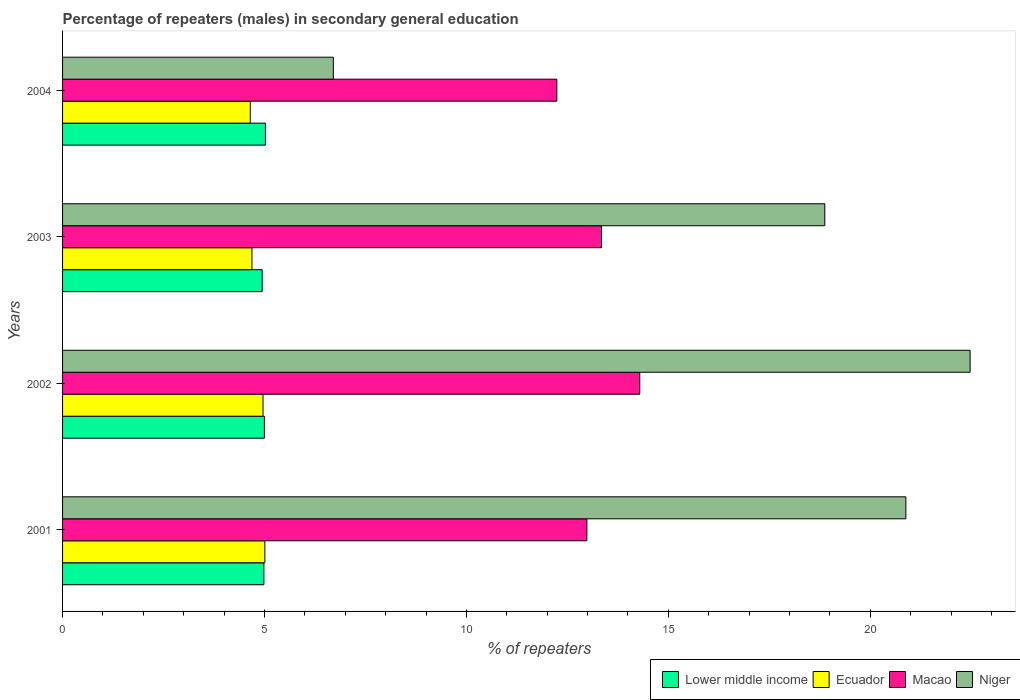How many groups of bars are there?
Offer a terse response. 4. Are the number of bars per tick equal to the number of legend labels?
Offer a terse response. Yes. Are the number of bars on each tick of the Y-axis equal?
Your response must be concise. Yes. How many bars are there on the 1st tick from the top?
Give a very brief answer. 4. How many bars are there on the 3rd tick from the bottom?
Make the answer very short. 4. What is the label of the 3rd group of bars from the top?
Offer a very short reply. 2002. What is the percentage of male repeaters in Lower middle income in 2001?
Provide a succinct answer. 4.99. Across all years, what is the maximum percentage of male repeaters in Macao?
Offer a terse response. 14.29. Across all years, what is the minimum percentage of male repeaters in Niger?
Make the answer very short. 6.71. In which year was the percentage of male repeaters in Macao maximum?
Give a very brief answer. 2002. What is the total percentage of male repeaters in Macao in the graph?
Ensure brevity in your answer.  52.86. What is the difference between the percentage of male repeaters in Lower middle income in 2001 and that in 2004?
Your answer should be very brief. -0.04. What is the difference between the percentage of male repeaters in Niger in 2004 and the percentage of male repeaters in Lower middle income in 2003?
Provide a short and direct response. 1.76. What is the average percentage of male repeaters in Niger per year?
Give a very brief answer. 17.23. In the year 2004, what is the difference between the percentage of male repeaters in Macao and percentage of male repeaters in Niger?
Keep it short and to the point. 5.53. In how many years, is the percentage of male repeaters in Macao greater than 5 %?
Provide a succinct answer. 4. What is the ratio of the percentage of male repeaters in Macao in 2001 to that in 2004?
Make the answer very short. 1.06. Is the percentage of male repeaters in Niger in 2003 less than that in 2004?
Give a very brief answer. No. What is the difference between the highest and the second highest percentage of male repeaters in Macao?
Offer a terse response. 0.95. What is the difference between the highest and the lowest percentage of male repeaters in Lower middle income?
Make the answer very short. 0.08. In how many years, is the percentage of male repeaters in Ecuador greater than the average percentage of male repeaters in Ecuador taken over all years?
Ensure brevity in your answer.  2. Is it the case that in every year, the sum of the percentage of male repeaters in Macao and percentage of male repeaters in Niger is greater than the sum of percentage of male repeaters in Lower middle income and percentage of male repeaters in Ecuador?
Provide a succinct answer. No. What does the 4th bar from the top in 2003 represents?
Keep it short and to the point. Lower middle income. What does the 2nd bar from the bottom in 2001 represents?
Provide a succinct answer. Ecuador. What is the difference between two consecutive major ticks on the X-axis?
Provide a succinct answer. 5. Where does the legend appear in the graph?
Your response must be concise. Bottom right. How are the legend labels stacked?
Your response must be concise. Horizontal. What is the title of the graph?
Provide a succinct answer. Percentage of repeaters (males) in secondary general education. What is the label or title of the X-axis?
Your response must be concise. % of repeaters. What is the % of repeaters in Lower middle income in 2001?
Ensure brevity in your answer.  4.99. What is the % of repeaters of Ecuador in 2001?
Your response must be concise. 5.01. What is the % of repeaters of Macao in 2001?
Your response must be concise. 12.98. What is the % of repeaters in Niger in 2001?
Provide a short and direct response. 20.88. What is the % of repeaters of Lower middle income in 2002?
Ensure brevity in your answer.  5. What is the % of repeaters in Ecuador in 2002?
Your answer should be very brief. 4.96. What is the % of repeaters in Macao in 2002?
Provide a short and direct response. 14.29. What is the % of repeaters in Niger in 2002?
Keep it short and to the point. 22.47. What is the % of repeaters of Lower middle income in 2003?
Give a very brief answer. 4.94. What is the % of repeaters of Ecuador in 2003?
Offer a terse response. 4.69. What is the % of repeaters in Macao in 2003?
Ensure brevity in your answer.  13.34. What is the % of repeaters in Niger in 2003?
Provide a succinct answer. 18.87. What is the % of repeaters in Lower middle income in 2004?
Provide a short and direct response. 5.02. What is the % of repeaters of Ecuador in 2004?
Provide a short and direct response. 4.65. What is the % of repeaters of Macao in 2004?
Your response must be concise. 12.24. What is the % of repeaters in Niger in 2004?
Make the answer very short. 6.71. Across all years, what is the maximum % of repeaters of Lower middle income?
Your answer should be compact. 5.02. Across all years, what is the maximum % of repeaters of Ecuador?
Your answer should be compact. 5.01. Across all years, what is the maximum % of repeaters of Macao?
Provide a succinct answer. 14.29. Across all years, what is the maximum % of repeaters in Niger?
Make the answer very short. 22.47. Across all years, what is the minimum % of repeaters in Lower middle income?
Give a very brief answer. 4.94. Across all years, what is the minimum % of repeaters of Ecuador?
Your answer should be very brief. 4.65. Across all years, what is the minimum % of repeaters of Macao?
Ensure brevity in your answer.  12.24. Across all years, what is the minimum % of repeaters in Niger?
Your response must be concise. 6.71. What is the total % of repeaters in Lower middle income in the graph?
Ensure brevity in your answer.  19.95. What is the total % of repeaters of Ecuador in the graph?
Your response must be concise. 19.31. What is the total % of repeaters of Macao in the graph?
Keep it short and to the point. 52.86. What is the total % of repeaters of Niger in the graph?
Keep it short and to the point. 68.94. What is the difference between the % of repeaters of Lower middle income in 2001 and that in 2002?
Provide a short and direct response. -0.01. What is the difference between the % of repeaters of Ecuador in 2001 and that in 2002?
Make the answer very short. 0.05. What is the difference between the % of repeaters of Macao in 2001 and that in 2002?
Your response must be concise. -1.31. What is the difference between the % of repeaters of Niger in 2001 and that in 2002?
Make the answer very short. -1.59. What is the difference between the % of repeaters of Lower middle income in 2001 and that in 2003?
Keep it short and to the point. 0.04. What is the difference between the % of repeaters of Ecuador in 2001 and that in 2003?
Provide a short and direct response. 0.32. What is the difference between the % of repeaters of Macao in 2001 and that in 2003?
Your response must be concise. -0.36. What is the difference between the % of repeaters in Niger in 2001 and that in 2003?
Keep it short and to the point. 2.01. What is the difference between the % of repeaters in Lower middle income in 2001 and that in 2004?
Offer a terse response. -0.04. What is the difference between the % of repeaters of Ecuador in 2001 and that in 2004?
Ensure brevity in your answer.  0.36. What is the difference between the % of repeaters in Macao in 2001 and that in 2004?
Provide a short and direct response. 0.74. What is the difference between the % of repeaters in Niger in 2001 and that in 2004?
Your answer should be very brief. 14.18. What is the difference between the % of repeaters of Lower middle income in 2002 and that in 2003?
Provide a short and direct response. 0.05. What is the difference between the % of repeaters in Ecuador in 2002 and that in 2003?
Your response must be concise. 0.27. What is the difference between the % of repeaters of Macao in 2002 and that in 2003?
Ensure brevity in your answer.  0.95. What is the difference between the % of repeaters in Niger in 2002 and that in 2003?
Give a very brief answer. 3.6. What is the difference between the % of repeaters in Lower middle income in 2002 and that in 2004?
Offer a very short reply. -0.03. What is the difference between the % of repeaters of Ecuador in 2002 and that in 2004?
Keep it short and to the point. 0.32. What is the difference between the % of repeaters of Macao in 2002 and that in 2004?
Keep it short and to the point. 2.05. What is the difference between the % of repeaters of Niger in 2002 and that in 2004?
Ensure brevity in your answer.  15.77. What is the difference between the % of repeaters in Lower middle income in 2003 and that in 2004?
Your answer should be very brief. -0.08. What is the difference between the % of repeaters in Ecuador in 2003 and that in 2004?
Provide a succinct answer. 0.04. What is the difference between the % of repeaters of Macao in 2003 and that in 2004?
Make the answer very short. 1.11. What is the difference between the % of repeaters of Niger in 2003 and that in 2004?
Your answer should be compact. 12.17. What is the difference between the % of repeaters in Lower middle income in 2001 and the % of repeaters in Ecuador in 2002?
Offer a very short reply. 0.02. What is the difference between the % of repeaters of Lower middle income in 2001 and the % of repeaters of Macao in 2002?
Provide a short and direct response. -9.31. What is the difference between the % of repeaters of Lower middle income in 2001 and the % of repeaters of Niger in 2002?
Offer a very short reply. -17.49. What is the difference between the % of repeaters of Ecuador in 2001 and the % of repeaters of Macao in 2002?
Your answer should be compact. -9.28. What is the difference between the % of repeaters in Ecuador in 2001 and the % of repeaters in Niger in 2002?
Offer a very short reply. -17.46. What is the difference between the % of repeaters in Macao in 2001 and the % of repeaters in Niger in 2002?
Your answer should be compact. -9.49. What is the difference between the % of repeaters of Lower middle income in 2001 and the % of repeaters of Ecuador in 2003?
Provide a short and direct response. 0.3. What is the difference between the % of repeaters in Lower middle income in 2001 and the % of repeaters in Macao in 2003?
Provide a succinct answer. -8.36. What is the difference between the % of repeaters of Lower middle income in 2001 and the % of repeaters of Niger in 2003?
Provide a succinct answer. -13.89. What is the difference between the % of repeaters in Ecuador in 2001 and the % of repeaters in Macao in 2003?
Make the answer very short. -8.34. What is the difference between the % of repeaters in Ecuador in 2001 and the % of repeaters in Niger in 2003?
Your answer should be compact. -13.87. What is the difference between the % of repeaters in Macao in 2001 and the % of repeaters in Niger in 2003?
Your answer should be compact. -5.89. What is the difference between the % of repeaters of Lower middle income in 2001 and the % of repeaters of Ecuador in 2004?
Ensure brevity in your answer.  0.34. What is the difference between the % of repeaters of Lower middle income in 2001 and the % of repeaters of Macao in 2004?
Give a very brief answer. -7.25. What is the difference between the % of repeaters of Lower middle income in 2001 and the % of repeaters of Niger in 2004?
Offer a very short reply. -1.72. What is the difference between the % of repeaters of Ecuador in 2001 and the % of repeaters of Macao in 2004?
Your response must be concise. -7.23. What is the difference between the % of repeaters of Ecuador in 2001 and the % of repeaters of Niger in 2004?
Ensure brevity in your answer.  -1.7. What is the difference between the % of repeaters of Macao in 2001 and the % of repeaters of Niger in 2004?
Keep it short and to the point. 6.28. What is the difference between the % of repeaters of Lower middle income in 2002 and the % of repeaters of Ecuador in 2003?
Your answer should be compact. 0.31. What is the difference between the % of repeaters in Lower middle income in 2002 and the % of repeaters in Macao in 2003?
Your response must be concise. -8.35. What is the difference between the % of repeaters of Lower middle income in 2002 and the % of repeaters of Niger in 2003?
Ensure brevity in your answer.  -13.88. What is the difference between the % of repeaters of Ecuador in 2002 and the % of repeaters of Macao in 2003?
Give a very brief answer. -8.38. What is the difference between the % of repeaters in Ecuador in 2002 and the % of repeaters in Niger in 2003?
Your response must be concise. -13.91. What is the difference between the % of repeaters of Macao in 2002 and the % of repeaters of Niger in 2003?
Make the answer very short. -4.58. What is the difference between the % of repeaters of Lower middle income in 2002 and the % of repeaters of Ecuador in 2004?
Provide a succinct answer. 0.35. What is the difference between the % of repeaters of Lower middle income in 2002 and the % of repeaters of Macao in 2004?
Your answer should be very brief. -7.24. What is the difference between the % of repeaters of Lower middle income in 2002 and the % of repeaters of Niger in 2004?
Provide a succinct answer. -1.71. What is the difference between the % of repeaters of Ecuador in 2002 and the % of repeaters of Macao in 2004?
Provide a short and direct response. -7.27. What is the difference between the % of repeaters of Ecuador in 2002 and the % of repeaters of Niger in 2004?
Your answer should be very brief. -1.74. What is the difference between the % of repeaters in Macao in 2002 and the % of repeaters in Niger in 2004?
Keep it short and to the point. 7.59. What is the difference between the % of repeaters in Lower middle income in 2003 and the % of repeaters in Ecuador in 2004?
Ensure brevity in your answer.  0.29. What is the difference between the % of repeaters of Lower middle income in 2003 and the % of repeaters of Macao in 2004?
Keep it short and to the point. -7.3. What is the difference between the % of repeaters of Lower middle income in 2003 and the % of repeaters of Niger in 2004?
Keep it short and to the point. -1.76. What is the difference between the % of repeaters in Ecuador in 2003 and the % of repeaters in Macao in 2004?
Your answer should be compact. -7.55. What is the difference between the % of repeaters of Ecuador in 2003 and the % of repeaters of Niger in 2004?
Offer a terse response. -2.02. What is the difference between the % of repeaters of Macao in 2003 and the % of repeaters of Niger in 2004?
Your answer should be compact. 6.64. What is the average % of repeaters in Lower middle income per year?
Offer a very short reply. 4.99. What is the average % of repeaters of Ecuador per year?
Offer a very short reply. 4.83. What is the average % of repeaters in Macao per year?
Your answer should be compact. 13.21. What is the average % of repeaters of Niger per year?
Offer a very short reply. 17.23. In the year 2001, what is the difference between the % of repeaters of Lower middle income and % of repeaters of Ecuador?
Your response must be concise. -0.02. In the year 2001, what is the difference between the % of repeaters of Lower middle income and % of repeaters of Macao?
Keep it short and to the point. -8. In the year 2001, what is the difference between the % of repeaters of Lower middle income and % of repeaters of Niger?
Offer a terse response. -15.9. In the year 2001, what is the difference between the % of repeaters of Ecuador and % of repeaters of Macao?
Keep it short and to the point. -7.97. In the year 2001, what is the difference between the % of repeaters in Ecuador and % of repeaters in Niger?
Provide a succinct answer. -15.87. In the year 2001, what is the difference between the % of repeaters in Macao and % of repeaters in Niger?
Ensure brevity in your answer.  -7.9. In the year 2002, what is the difference between the % of repeaters of Lower middle income and % of repeaters of Ecuador?
Keep it short and to the point. 0.03. In the year 2002, what is the difference between the % of repeaters of Lower middle income and % of repeaters of Macao?
Offer a terse response. -9.3. In the year 2002, what is the difference between the % of repeaters of Lower middle income and % of repeaters of Niger?
Your response must be concise. -17.48. In the year 2002, what is the difference between the % of repeaters of Ecuador and % of repeaters of Macao?
Make the answer very short. -9.33. In the year 2002, what is the difference between the % of repeaters of Ecuador and % of repeaters of Niger?
Offer a very short reply. -17.51. In the year 2002, what is the difference between the % of repeaters in Macao and % of repeaters in Niger?
Your response must be concise. -8.18. In the year 2003, what is the difference between the % of repeaters in Lower middle income and % of repeaters in Ecuador?
Make the answer very short. 0.25. In the year 2003, what is the difference between the % of repeaters in Lower middle income and % of repeaters in Macao?
Ensure brevity in your answer.  -8.4. In the year 2003, what is the difference between the % of repeaters of Lower middle income and % of repeaters of Niger?
Make the answer very short. -13.93. In the year 2003, what is the difference between the % of repeaters of Ecuador and % of repeaters of Macao?
Your response must be concise. -8.66. In the year 2003, what is the difference between the % of repeaters in Ecuador and % of repeaters in Niger?
Provide a succinct answer. -14.19. In the year 2003, what is the difference between the % of repeaters of Macao and % of repeaters of Niger?
Your answer should be very brief. -5.53. In the year 2004, what is the difference between the % of repeaters of Lower middle income and % of repeaters of Ecuador?
Your answer should be compact. 0.37. In the year 2004, what is the difference between the % of repeaters in Lower middle income and % of repeaters in Macao?
Give a very brief answer. -7.22. In the year 2004, what is the difference between the % of repeaters of Lower middle income and % of repeaters of Niger?
Your answer should be compact. -1.68. In the year 2004, what is the difference between the % of repeaters of Ecuador and % of repeaters of Macao?
Offer a terse response. -7.59. In the year 2004, what is the difference between the % of repeaters of Ecuador and % of repeaters of Niger?
Offer a very short reply. -2.06. In the year 2004, what is the difference between the % of repeaters in Macao and % of repeaters in Niger?
Your answer should be very brief. 5.53. What is the ratio of the % of repeaters in Lower middle income in 2001 to that in 2002?
Give a very brief answer. 1. What is the ratio of the % of repeaters of Ecuador in 2001 to that in 2002?
Ensure brevity in your answer.  1.01. What is the ratio of the % of repeaters in Macao in 2001 to that in 2002?
Your answer should be compact. 0.91. What is the ratio of the % of repeaters in Niger in 2001 to that in 2002?
Your answer should be compact. 0.93. What is the ratio of the % of repeaters in Lower middle income in 2001 to that in 2003?
Your answer should be compact. 1.01. What is the ratio of the % of repeaters in Ecuador in 2001 to that in 2003?
Offer a very short reply. 1.07. What is the ratio of the % of repeaters in Macao in 2001 to that in 2003?
Provide a short and direct response. 0.97. What is the ratio of the % of repeaters in Niger in 2001 to that in 2003?
Your answer should be compact. 1.11. What is the ratio of the % of repeaters in Lower middle income in 2001 to that in 2004?
Offer a very short reply. 0.99. What is the ratio of the % of repeaters in Ecuador in 2001 to that in 2004?
Offer a very short reply. 1.08. What is the ratio of the % of repeaters of Macao in 2001 to that in 2004?
Offer a very short reply. 1.06. What is the ratio of the % of repeaters in Niger in 2001 to that in 2004?
Offer a terse response. 3.11. What is the ratio of the % of repeaters of Lower middle income in 2002 to that in 2003?
Give a very brief answer. 1.01. What is the ratio of the % of repeaters of Ecuador in 2002 to that in 2003?
Make the answer very short. 1.06. What is the ratio of the % of repeaters of Macao in 2002 to that in 2003?
Provide a short and direct response. 1.07. What is the ratio of the % of repeaters in Niger in 2002 to that in 2003?
Offer a terse response. 1.19. What is the ratio of the % of repeaters in Lower middle income in 2002 to that in 2004?
Provide a succinct answer. 0.99. What is the ratio of the % of repeaters of Ecuador in 2002 to that in 2004?
Ensure brevity in your answer.  1.07. What is the ratio of the % of repeaters of Macao in 2002 to that in 2004?
Your answer should be compact. 1.17. What is the ratio of the % of repeaters of Niger in 2002 to that in 2004?
Provide a short and direct response. 3.35. What is the ratio of the % of repeaters in Lower middle income in 2003 to that in 2004?
Offer a terse response. 0.98. What is the ratio of the % of repeaters in Ecuador in 2003 to that in 2004?
Give a very brief answer. 1.01. What is the ratio of the % of repeaters of Macao in 2003 to that in 2004?
Your answer should be very brief. 1.09. What is the ratio of the % of repeaters of Niger in 2003 to that in 2004?
Provide a succinct answer. 2.81. What is the difference between the highest and the second highest % of repeaters in Lower middle income?
Keep it short and to the point. 0.03. What is the difference between the highest and the second highest % of repeaters in Ecuador?
Your answer should be very brief. 0.05. What is the difference between the highest and the second highest % of repeaters in Macao?
Your response must be concise. 0.95. What is the difference between the highest and the second highest % of repeaters in Niger?
Make the answer very short. 1.59. What is the difference between the highest and the lowest % of repeaters of Ecuador?
Make the answer very short. 0.36. What is the difference between the highest and the lowest % of repeaters of Macao?
Provide a short and direct response. 2.05. What is the difference between the highest and the lowest % of repeaters of Niger?
Your response must be concise. 15.77. 